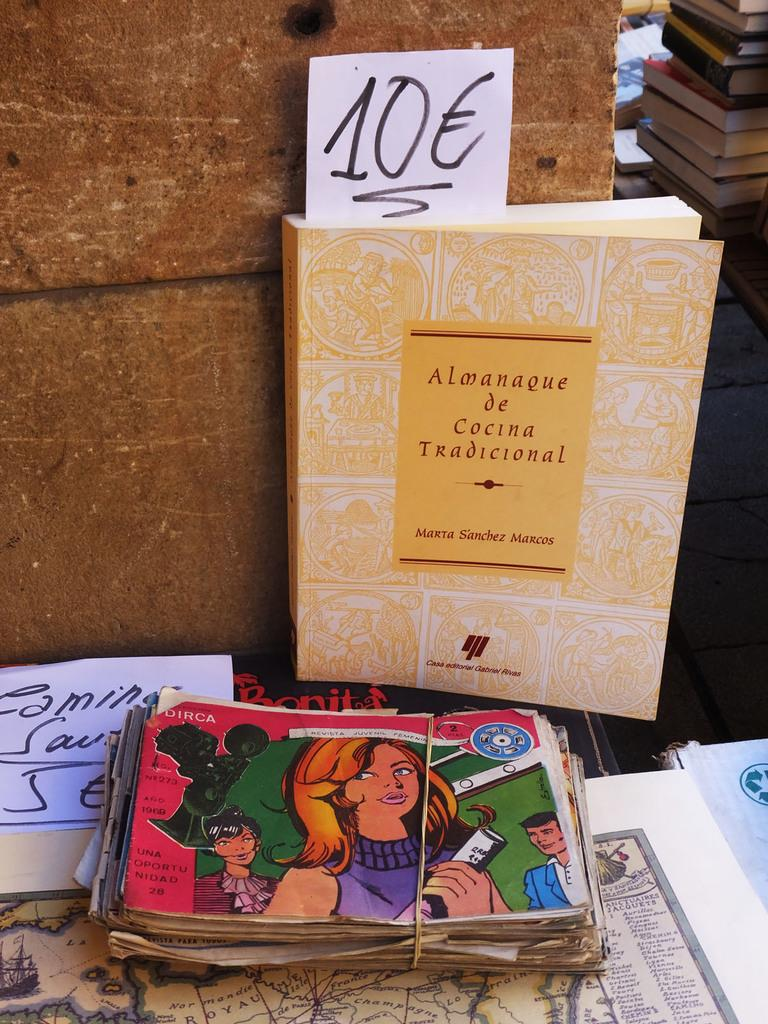What type of reading materials can be seen in the image? There are books, magazines, and paper in the image. What other type of informational materials can be seen in the image? There are maps in the image. What is visible in the background of the image? There is a wall in the image. Can you see the seashore in the image? There is no seashore present in the image. What type of observation can be made about the thumb in the image? There is no thumb present in the image. 